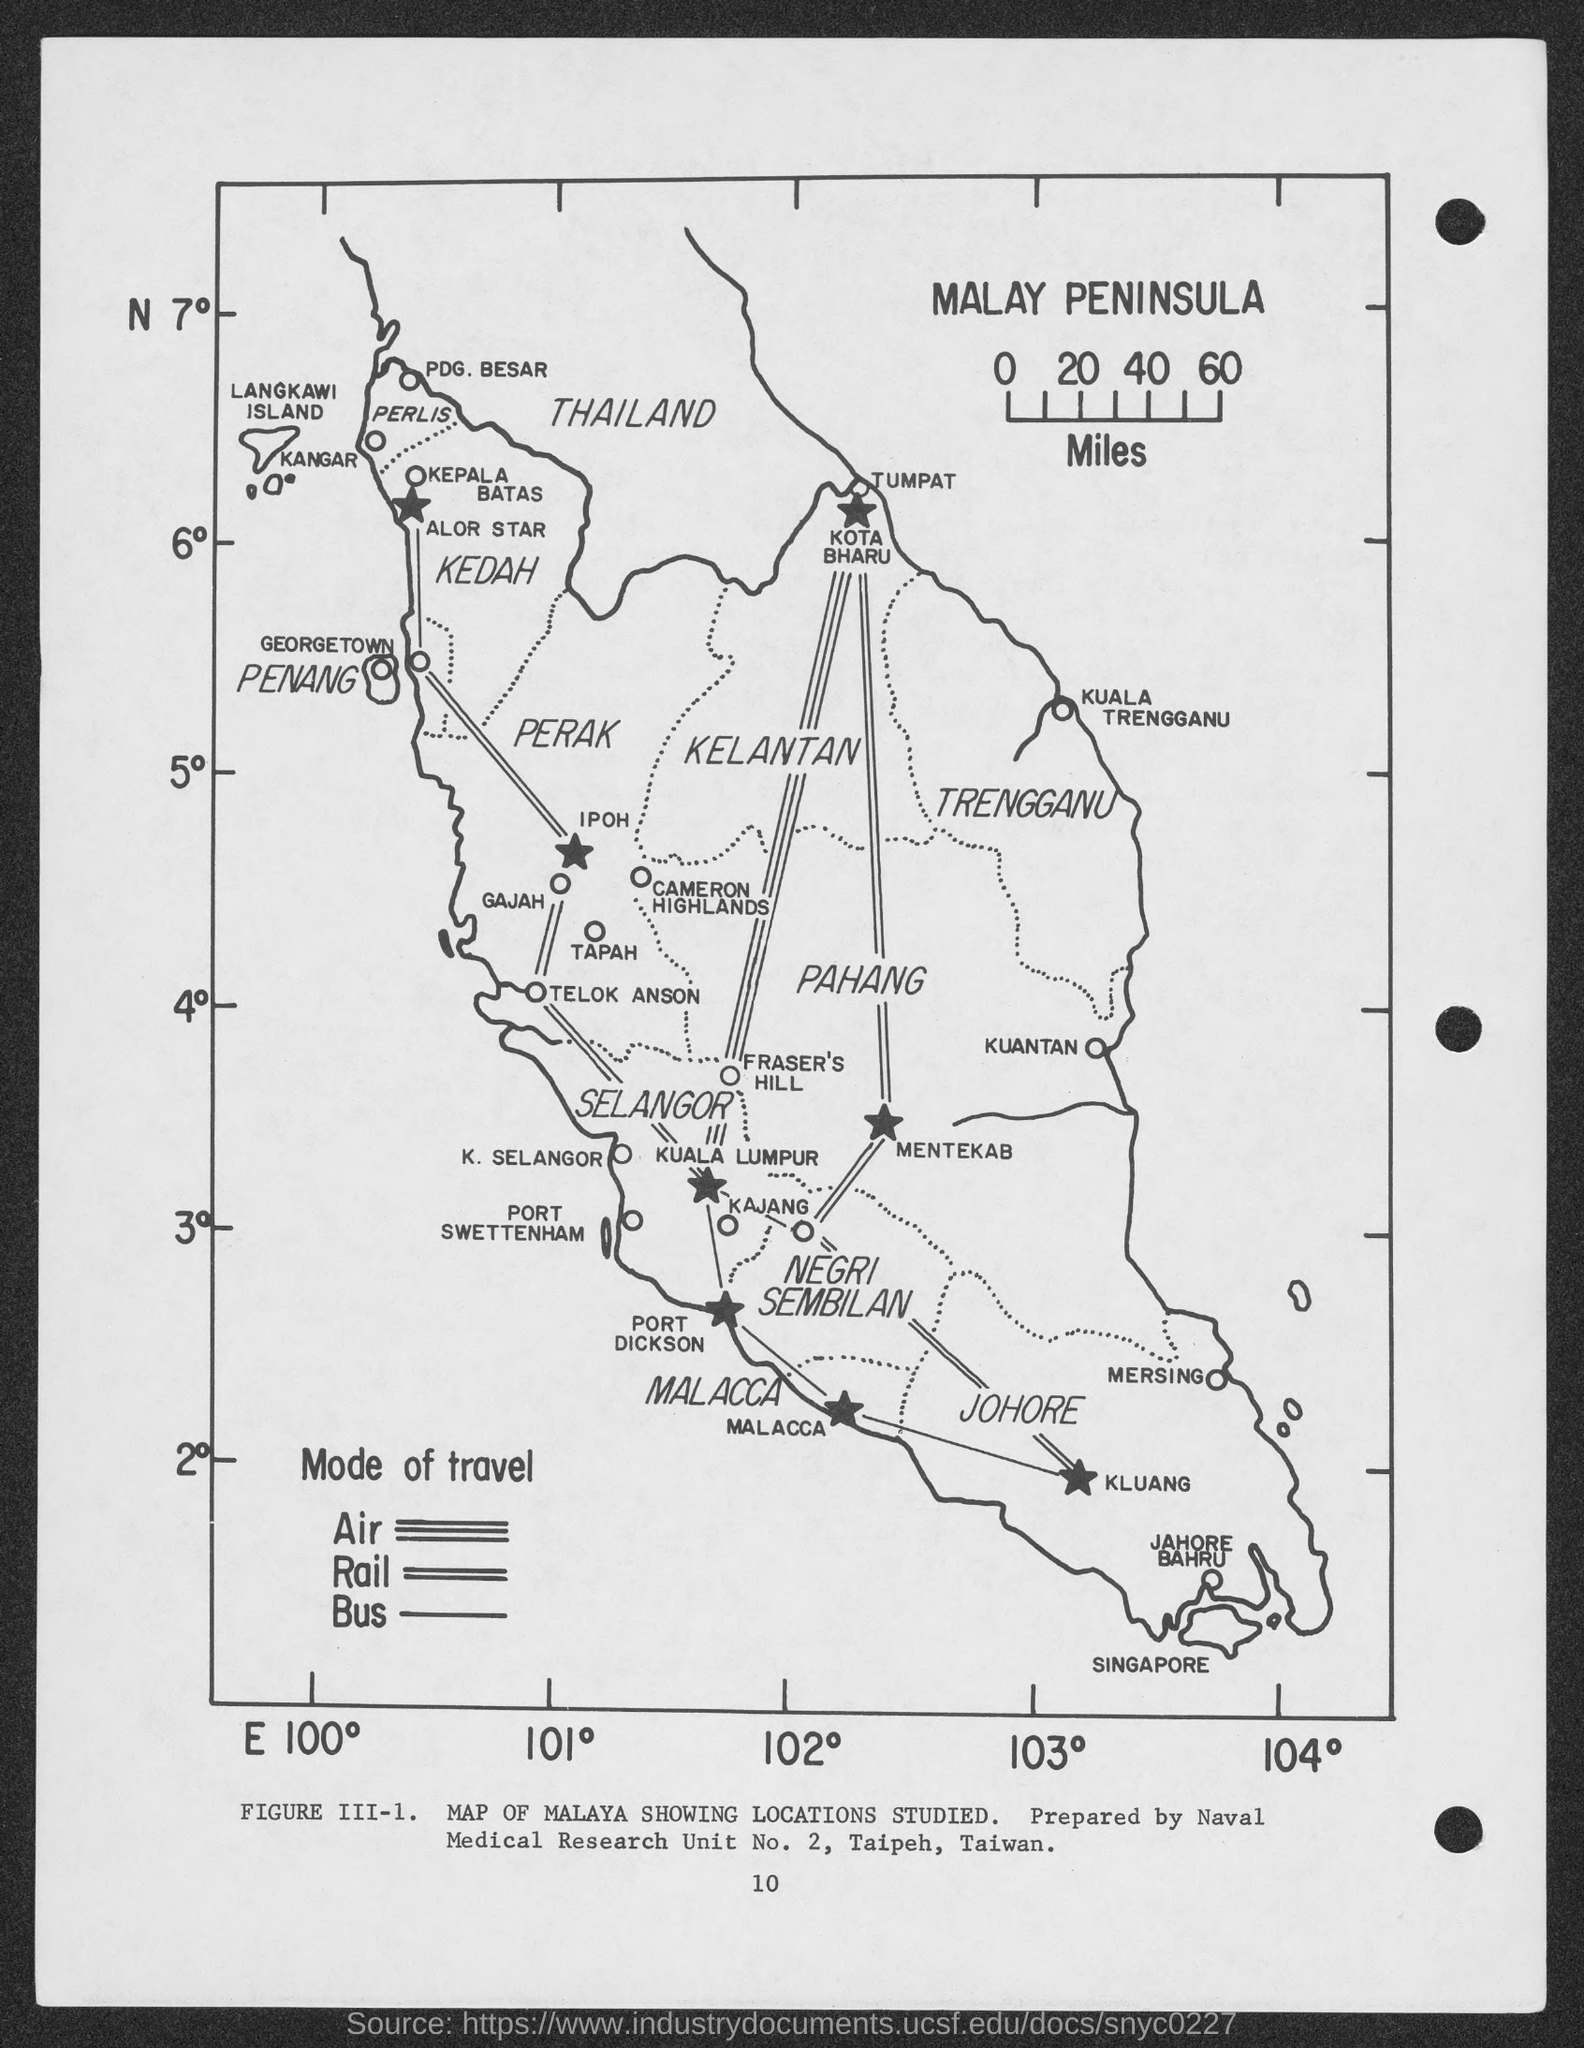What is the number at bottom of the page?
Your response must be concise. 10. 